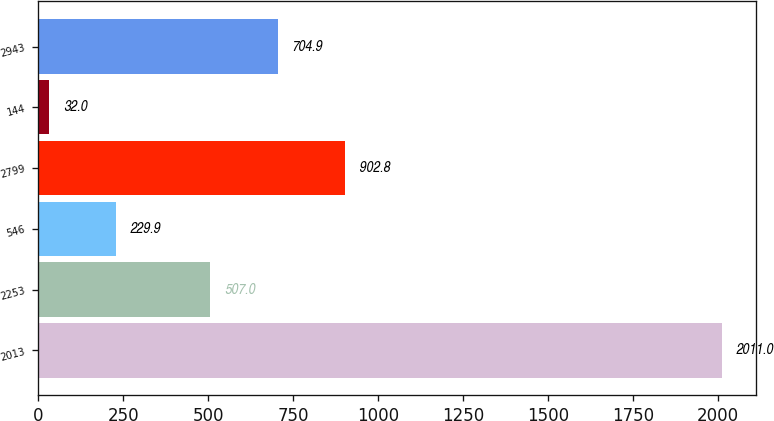Convert chart. <chart><loc_0><loc_0><loc_500><loc_500><bar_chart><fcel>2013<fcel>2253<fcel>546<fcel>2799<fcel>144<fcel>2943<nl><fcel>2011<fcel>507<fcel>229.9<fcel>902.8<fcel>32<fcel>704.9<nl></chart> 